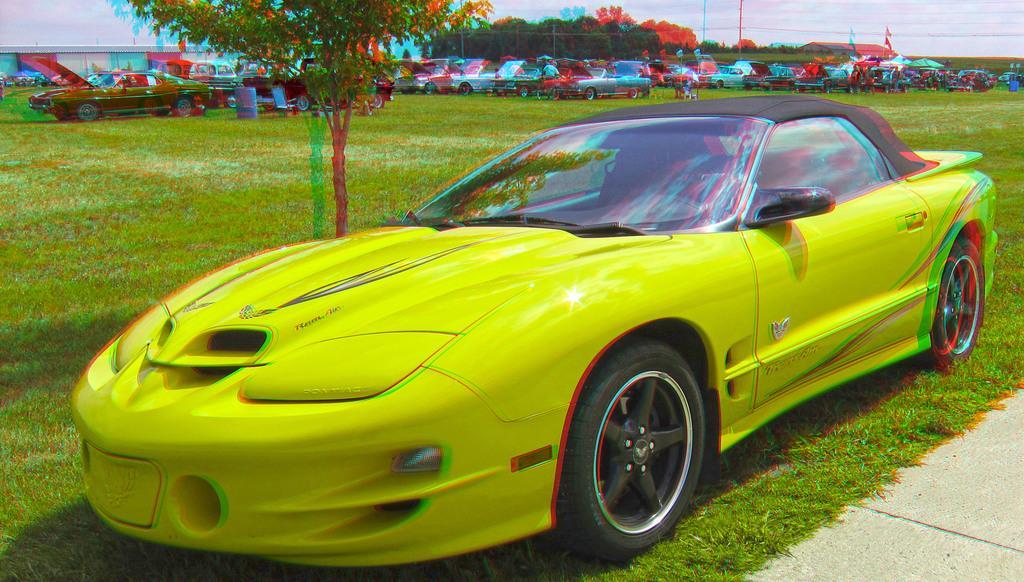Could you give a brief overview of what you see in this image? In this picture we can see trees, flags, poles, sky, vehicles, people, blue barrels. This picture is mainly highlighted with a yellow car. At the bottom portion of the picture we can see green grass and road. 